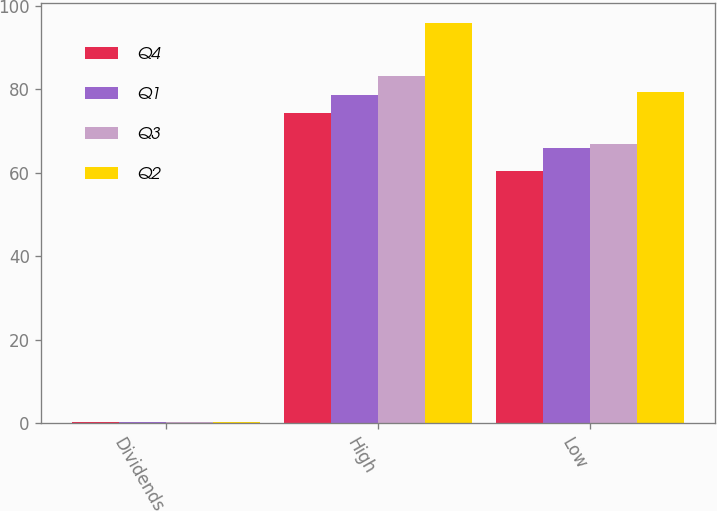<chart> <loc_0><loc_0><loc_500><loc_500><stacked_bar_chart><ecel><fcel>Dividends<fcel>High<fcel>Low<nl><fcel>Q4<fcel>0.27<fcel>74.35<fcel>60.41<nl><fcel>Q1<fcel>0.33<fcel>78.61<fcel>65.99<nl><fcel>Q3<fcel>0.33<fcel>83.08<fcel>66.84<nl><fcel>Q2<fcel>0.38<fcel>95.78<fcel>79.32<nl></chart> 